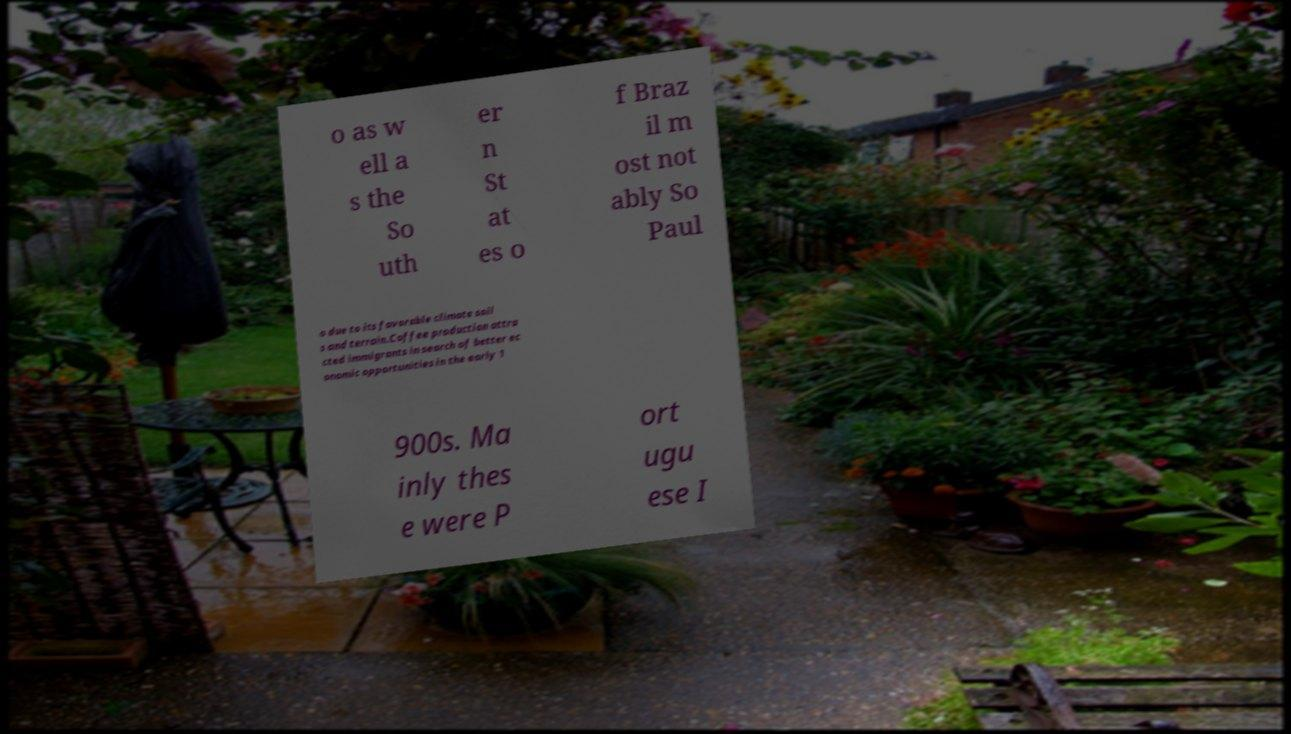What messages or text are displayed in this image? I need them in a readable, typed format. o as w ell a s the So uth er n St at es o f Braz il m ost not ably So Paul o due to its favorable climate soil s and terrain.Coffee production attra cted immigrants in search of better ec onomic opportunities in the early 1 900s. Ma inly thes e were P ort ugu ese I 